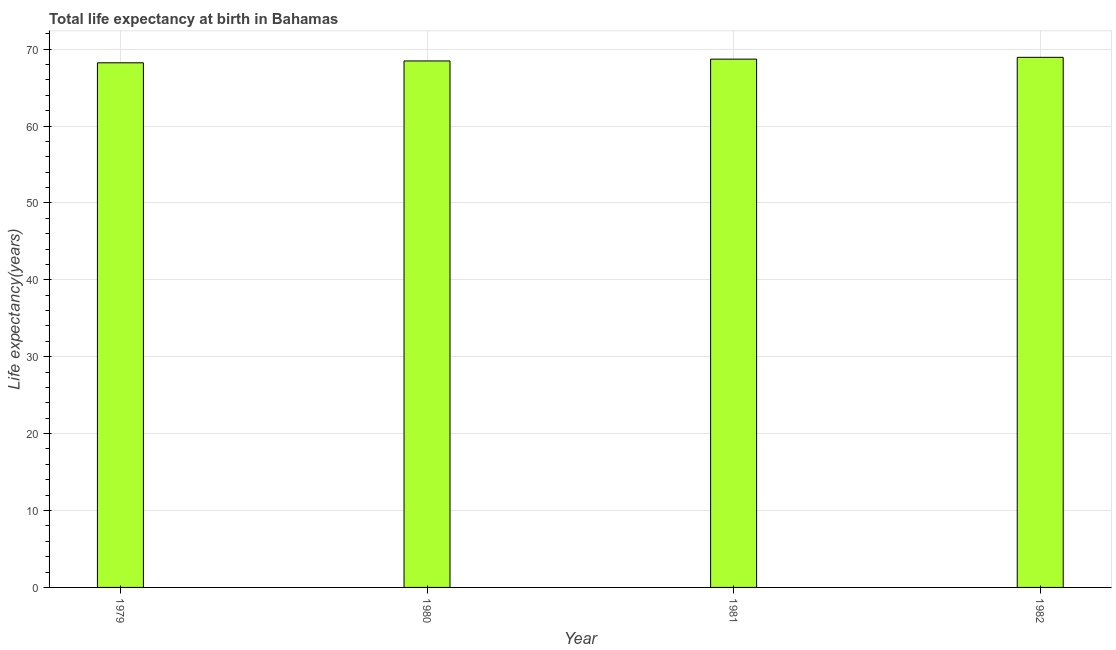Does the graph contain grids?
Offer a very short reply. Yes. What is the title of the graph?
Keep it short and to the point. Total life expectancy at birth in Bahamas. What is the label or title of the Y-axis?
Offer a very short reply. Life expectancy(years). What is the life expectancy at birth in 1980?
Give a very brief answer. 68.46. Across all years, what is the maximum life expectancy at birth?
Offer a very short reply. 68.93. Across all years, what is the minimum life expectancy at birth?
Keep it short and to the point. 68.22. In which year was the life expectancy at birth minimum?
Ensure brevity in your answer.  1979. What is the sum of the life expectancy at birth?
Give a very brief answer. 274.3. What is the difference between the life expectancy at birth in 1979 and 1980?
Your response must be concise. -0.24. What is the average life expectancy at birth per year?
Offer a very short reply. 68.58. What is the median life expectancy at birth?
Keep it short and to the point. 68.58. Is the difference between the life expectancy at birth in 1980 and 1981 greater than the difference between any two years?
Provide a short and direct response. No. What is the difference between the highest and the second highest life expectancy at birth?
Ensure brevity in your answer.  0.23. What is the difference between the highest and the lowest life expectancy at birth?
Your answer should be very brief. 0.71. How many years are there in the graph?
Provide a succinct answer. 4. What is the Life expectancy(years) in 1979?
Your response must be concise. 68.22. What is the Life expectancy(years) in 1980?
Your response must be concise. 68.46. What is the Life expectancy(years) of 1981?
Provide a succinct answer. 68.7. What is the Life expectancy(years) of 1982?
Offer a terse response. 68.93. What is the difference between the Life expectancy(years) in 1979 and 1980?
Make the answer very short. -0.24. What is the difference between the Life expectancy(years) in 1979 and 1981?
Give a very brief answer. -0.48. What is the difference between the Life expectancy(years) in 1979 and 1982?
Your response must be concise. -0.71. What is the difference between the Life expectancy(years) in 1980 and 1981?
Provide a short and direct response. -0.24. What is the difference between the Life expectancy(years) in 1980 and 1982?
Provide a short and direct response. -0.47. What is the difference between the Life expectancy(years) in 1981 and 1982?
Give a very brief answer. -0.23. What is the ratio of the Life expectancy(years) in 1979 to that in 1980?
Provide a succinct answer. 1. What is the ratio of the Life expectancy(years) in 1979 to that in 1981?
Your response must be concise. 0.99. What is the ratio of the Life expectancy(years) in 1979 to that in 1982?
Your answer should be very brief. 0.99. What is the ratio of the Life expectancy(years) in 1980 to that in 1982?
Make the answer very short. 0.99. 